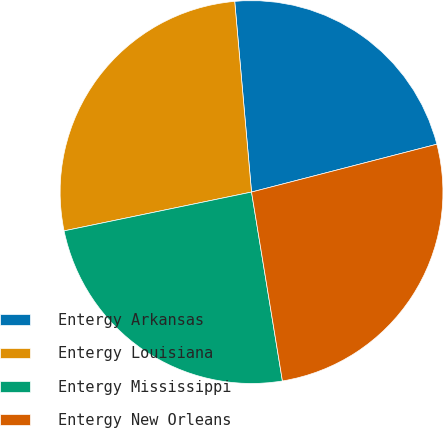Convert chart. <chart><loc_0><loc_0><loc_500><loc_500><pie_chart><fcel>Entergy Arkansas<fcel>Entergy Louisiana<fcel>Entergy Mississippi<fcel>Entergy New Orleans<nl><fcel>22.38%<fcel>26.85%<fcel>24.33%<fcel>26.44%<nl></chart> 